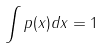<formula> <loc_0><loc_0><loc_500><loc_500>\int p ( x ) d x = 1</formula> 